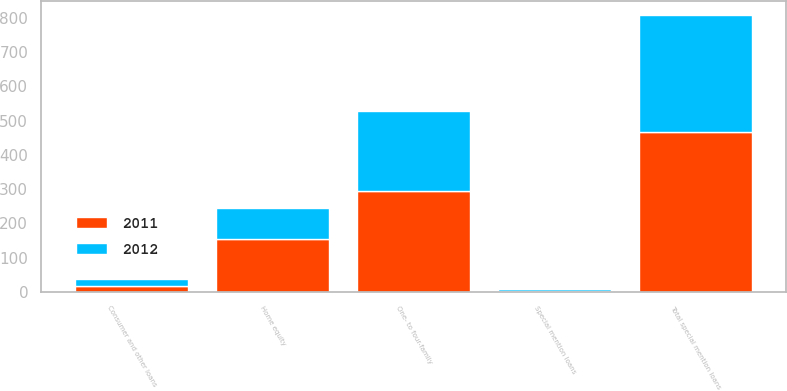Convert chart to OTSL. <chart><loc_0><loc_0><loc_500><loc_500><stacked_bar_chart><ecel><fcel>One- to four-family<fcel>Home equity<fcel>Consumer and other loans<fcel>Total special mention loans<fcel>Special mention loans<nl><fcel>2012<fcel>233.8<fcel>89.3<fcel>19.1<fcel>342.2<fcel>3.23<nl><fcel>2011<fcel>294.8<fcel>154.6<fcel>17.7<fcel>467.1<fcel>3.55<nl></chart> 